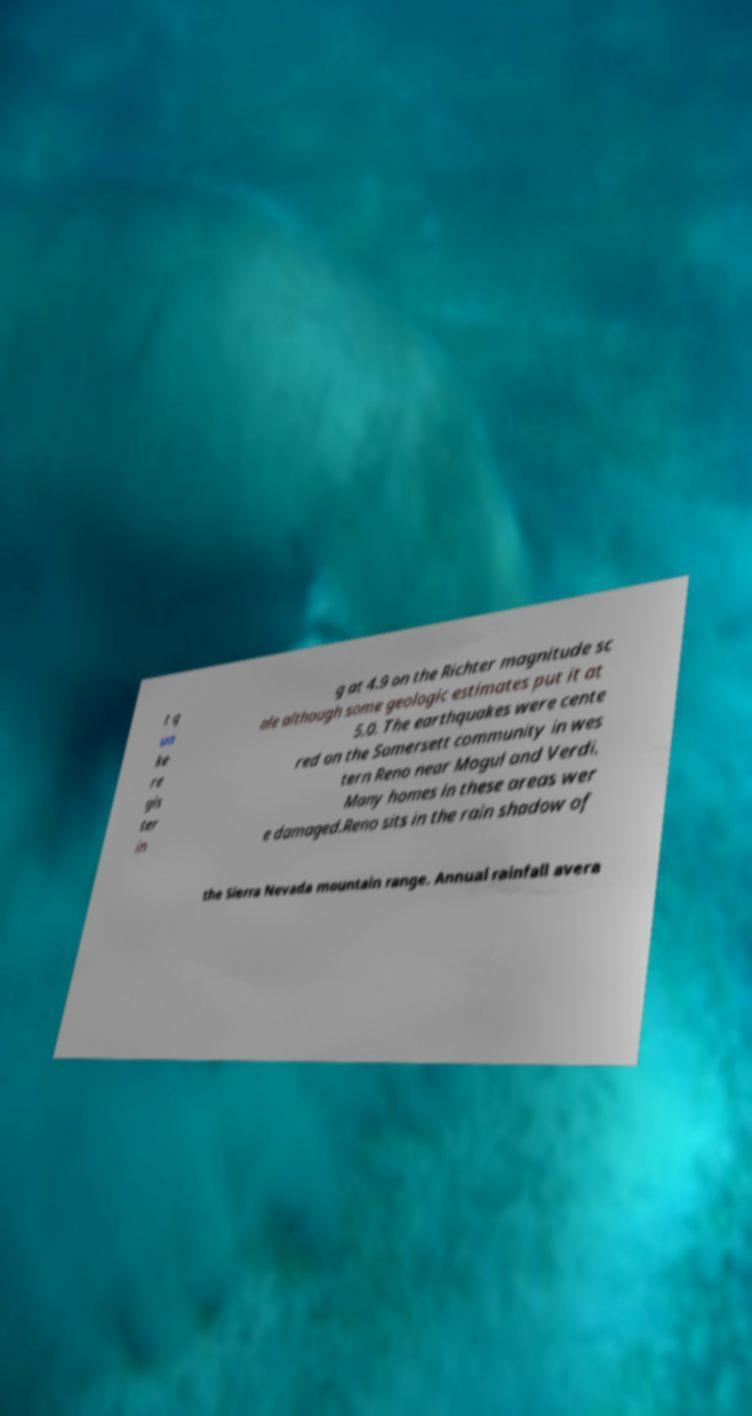Can you read and provide the text displayed in the image?This photo seems to have some interesting text. Can you extract and type it out for me? t q ua ke re gis ter in g at 4.9 on the Richter magnitude sc ale although some geologic estimates put it at 5.0. The earthquakes were cente red on the Somersett community in wes tern Reno near Mogul and Verdi. Many homes in these areas wer e damaged.Reno sits in the rain shadow of the Sierra Nevada mountain range. Annual rainfall avera 